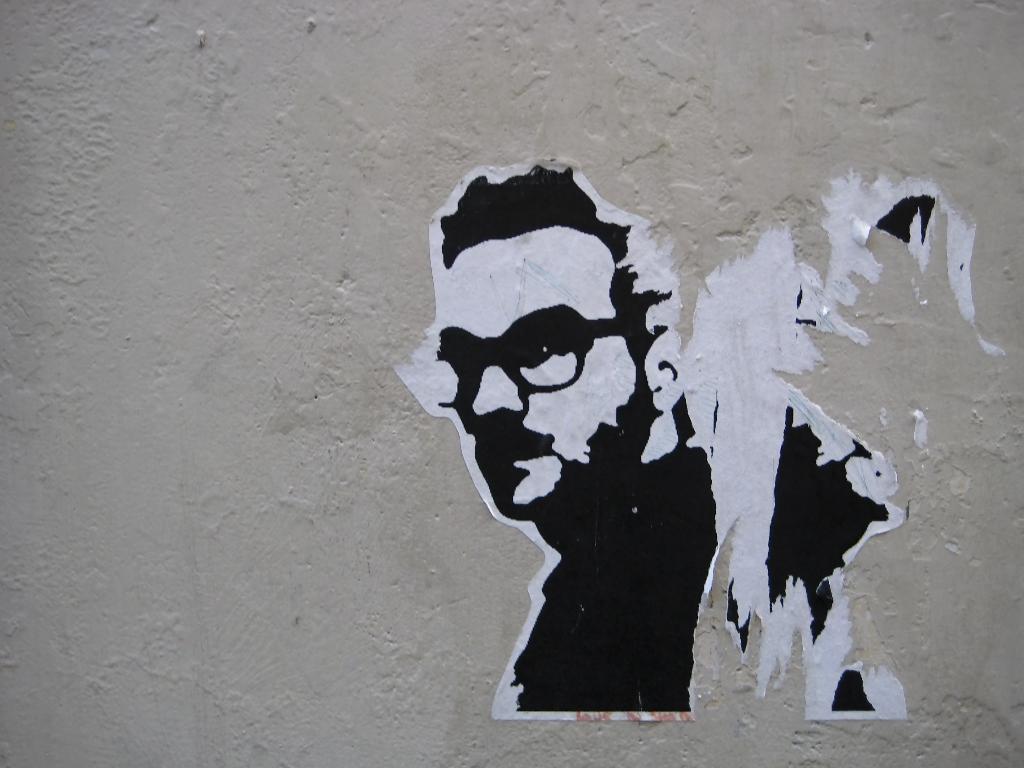Please provide a concise description of this image. In this image we can see a poster of a person on the wall. 